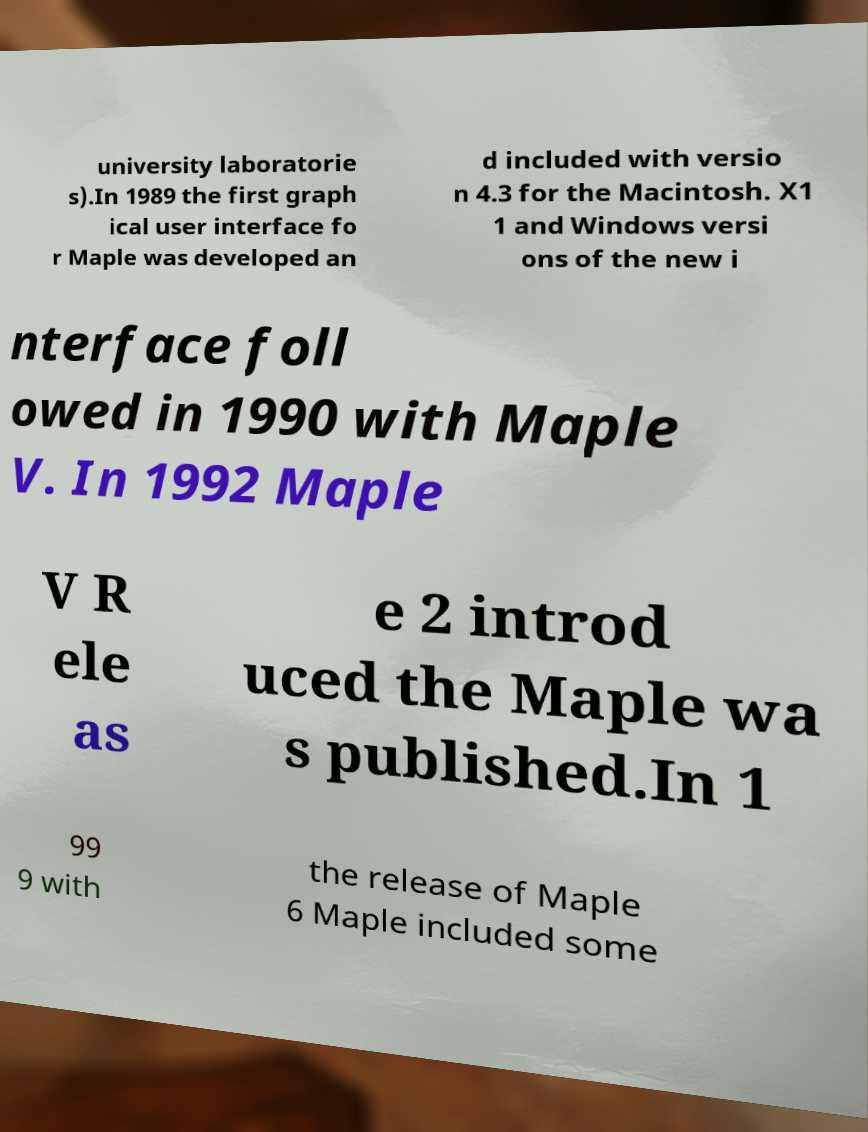Can you read and provide the text displayed in the image?This photo seems to have some interesting text. Can you extract and type it out for me? university laboratorie s).In 1989 the first graph ical user interface fo r Maple was developed an d included with versio n 4.3 for the Macintosh. X1 1 and Windows versi ons of the new i nterface foll owed in 1990 with Maple V. In 1992 Maple V R ele as e 2 introd uced the Maple wa s published.In 1 99 9 with the release of Maple 6 Maple included some 